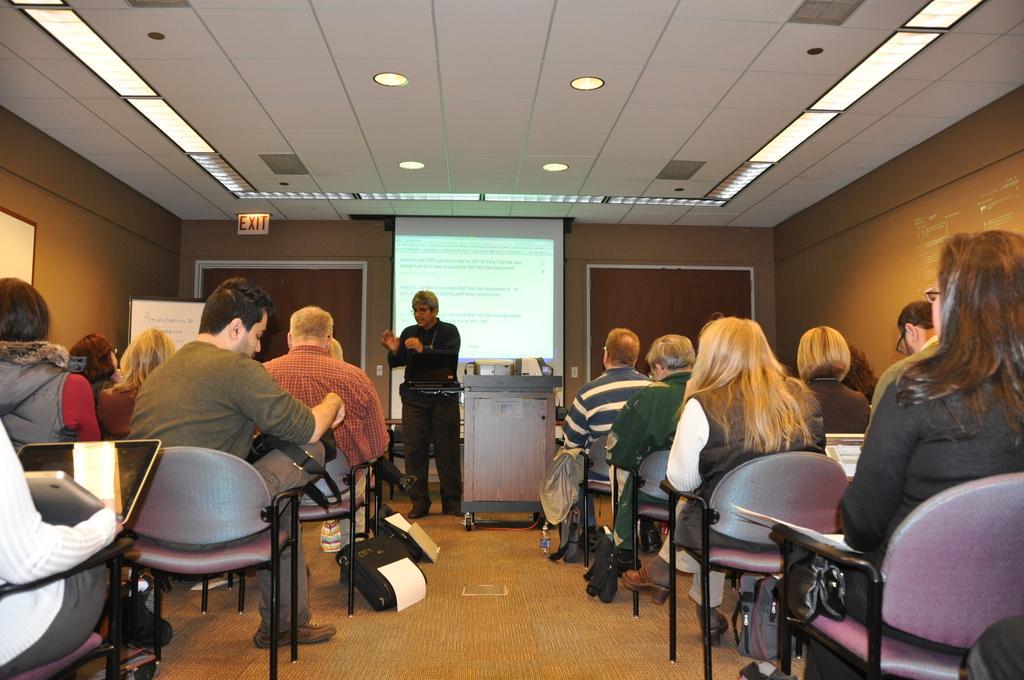Describe this image in one or two sentences. In this picture we can see some people sitting on chairs, in the background there is a projector screen, we can see a man standing here, there is a exit board, we can see the ceiling at the top of the picture, there are some lights, at the bottom we can see a paper and a bag. 